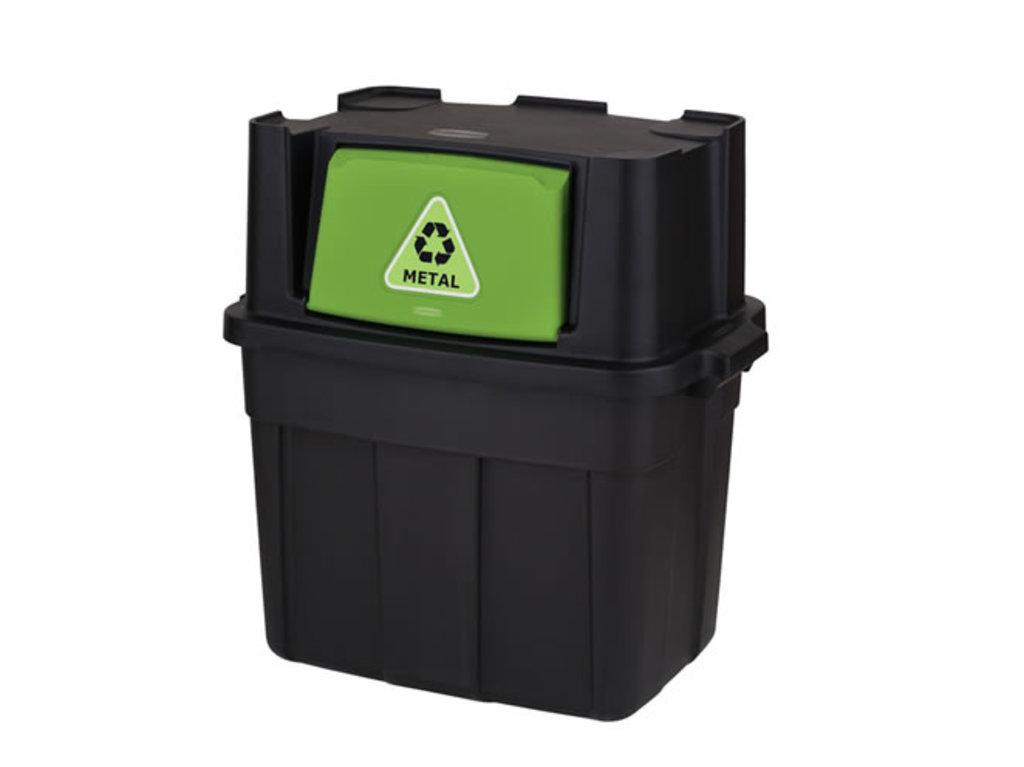What goes into this bin?
Ensure brevity in your answer.  Metal. 